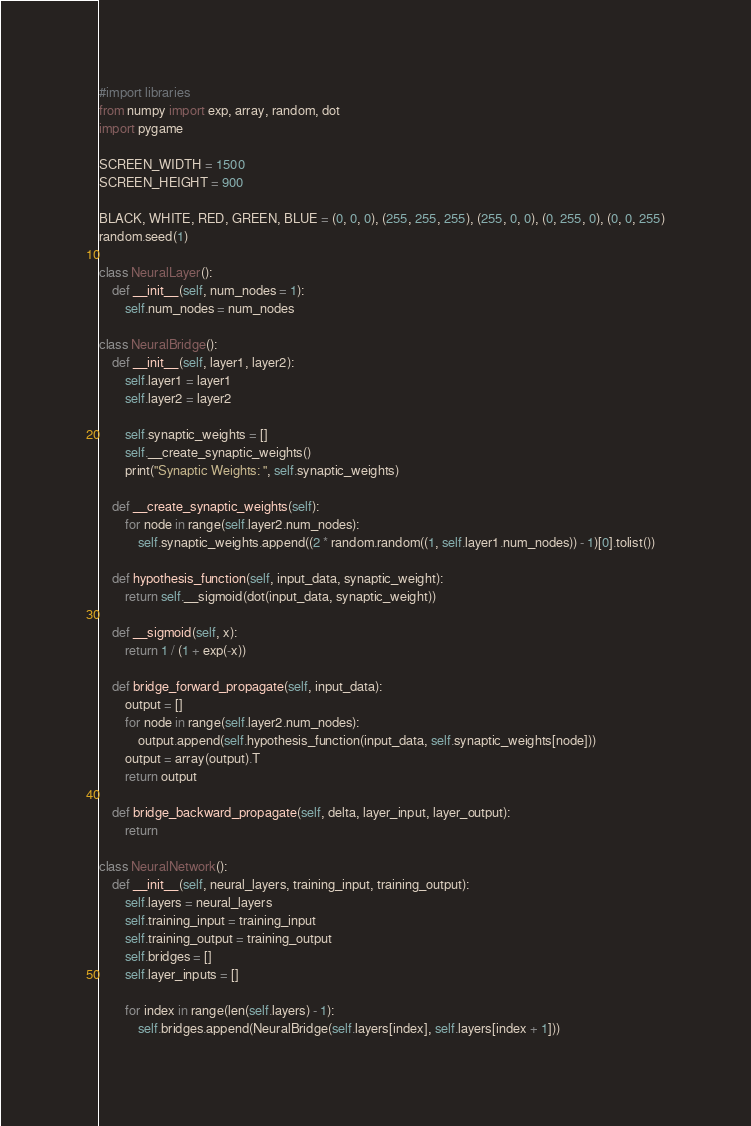Convert code to text. <code><loc_0><loc_0><loc_500><loc_500><_Python_>#import libraries
from numpy import exp, array, random, dot
import pygame

SCREEN_WIDTH = 1500
SCREEN_HEIGHT = 900

BLACK, WHITE, RED, GREEN, BLUE = (0, 0, 0), (255, 255, 255), (255, 0, 0), (0, 255, 0), (0, 0, 255)
random.seed(1)

class NeuralLayer():
    def __init__(self, num_nodes = 1):
        self.num_nodes = num_nodes

class NeuralBridge():
    def __init__(self, layer1, layer2):
        self.layer1 = layer1
        self.layer2 = layer2

        self.synaptic_weights = []
        self.__create_synaptic_weights()
        print("Synaptic Weights: ", self.synaptic_weights)

    def __create_synaptic_weights(self):
        for node in range(self.layer2.num_nodes):
            self.synaptic_weights.append((2 * random.random((1, self.layer1.num_nodes)) - 1)[0].tolist())

    def hypothesis_function(self, input_data, synaptic_weight):
        return self.__sigmoid(dot(input_data, synaptic_weight))

    def __sigmoid(self, x):
        return 1 / (1 + exp(-x))

    def bridge_forward_propagate(self, input_data):
        output = []
        for node in range(self.layer2.num_nodes):
            output.append(self.hypothesis_function(input_data, self.synaptic_weights[node]))
        output = array(output).T
        return output

    def bridge_backward_propagate(self, delta, layer_input, layer_output):
        return

class NeuralNetwork():
    def __init__(self, neural_layers, training_input, training_output):
        self.layers = neural_layers
        self.training_input = training_input
        self.training_output = training_output
        self.bridges = []
        self.layer_inputs = []

        for index in range(len(self.layers) - 1):
            self.bridges.append(NeuralBridge(self.layers[index], self.layers[index + 1]))
</code> 